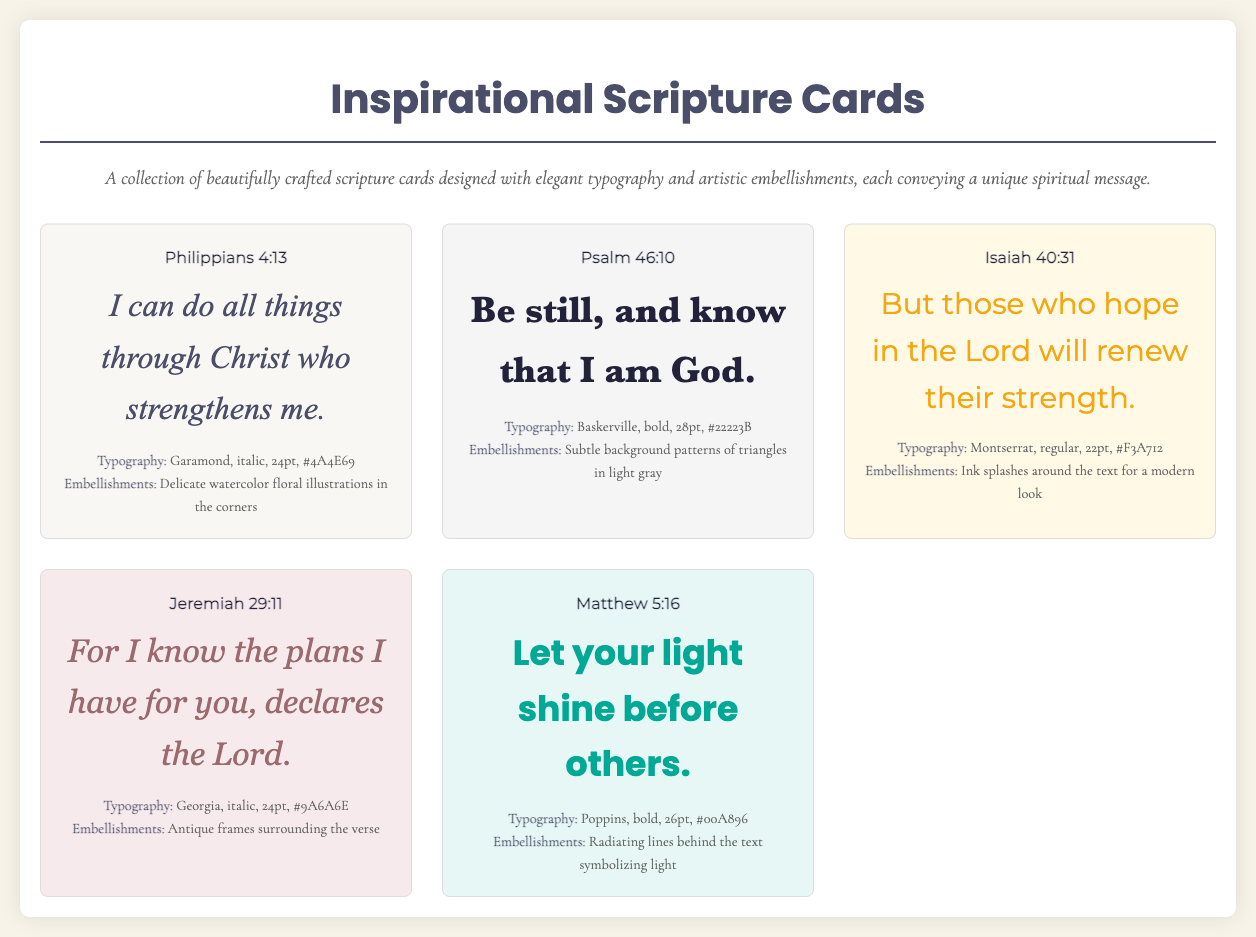What is the title of the catalog? The title of the catalog is prominently displayed at the top of the document.
Answer: Inspirational Scripture Cards How many scripture cards are featured in the document? Counting the number of cards described in the card grid section indicates the total number.
Answer: 5 What is the verse on the card for Philippians? Each card includes a specific verse, and Philippians 4:13 is mentioned clearly.
Answer: Philippians 4:13 Which typography is used for Isaiah 40:31? The specific typography for each card is detailed under the "Typography" section of each card.
Answer: Montserrat, regular, 22pt, #F3A712 What embellishments are used on the Jeremiah 29:11 card? Each card lists its unique embellishments, telling us how they are artistically enhanced.
Answer: Antique frames surrounding the verse Which color is used for the text of Matthew 5:16? The document includes the color specified for each verse's text, clearly stated in the card descriptions.
Answer: #00A896 What is the font style for the verse in Psalm 46:10? The document classifies the font styles used for various verses, particularly focusing on the Psalm 46:10 card.
Answer: bold What are the artistic embellishments for the card with Isaiah 40:31? Each card's embellishments enhance the overall design, and each is explicitly mentioned in the description.
Answer: Ink splashes around the text for a modern look 